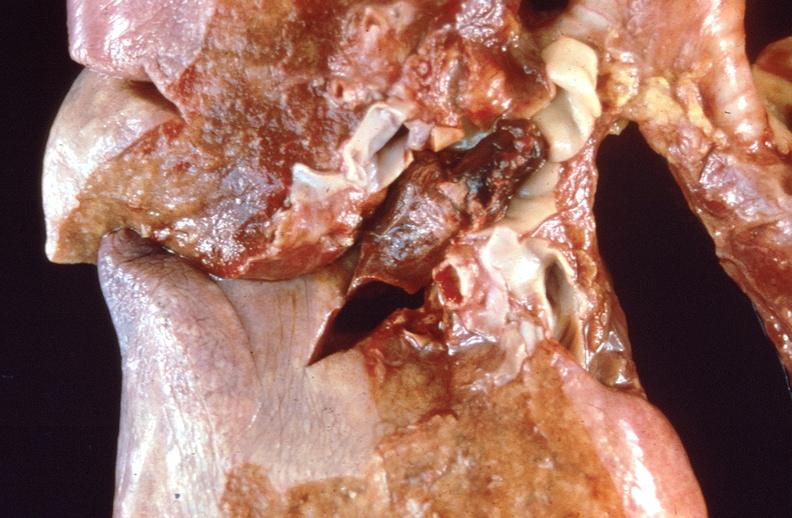what does this image show?
Answer the question using a single word or phrase. Pulmonary thromboemboli 